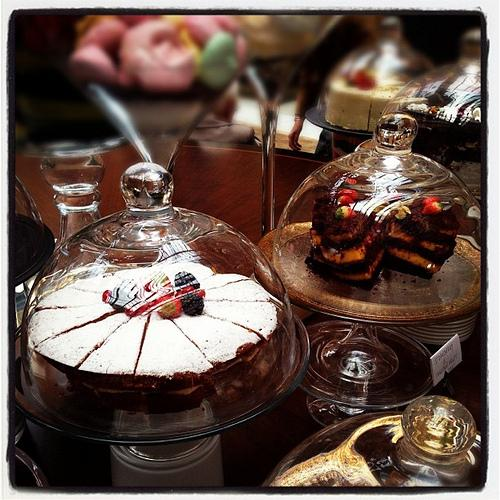What is the outstanding attribute on the image that makes it visually pleasant? The image has a clear reflection on the glass, creating an aesthetically pleasing visual effect. What is the pastry placed in, and what does it rest on? The pastry is placed in a glass cake container under a clear dome lid, resting on a wooden table. Enumerate the fruits on top of the cake. There are strawberries, a blackberry, and red raspberries on the cake. Describe the appearance of the cake's lid and its handle. The dome lid is made of clear glass, and it has a glass handle (knob) on top. Describe any human interaction or presence in the image. There is a hand of a person in the frame, possibly reaching out to grab a tasty dessert. How many cakes are under the dome cap, and are they partially eaten or fully intact? There are two cakes under the dome cap, one of which is partially eaten. What is the setting and ambiance of the scene in the image? The picture is taken in a bakery with a warm ambiance, showing various cakes and pastries in glass containers on a wood counter. Mention the color of the table and the kind of material it is made up of. The table is brown in color and made of wood. Provide a description of the cake along with its toppings and frosting. The cake is chocolate and white in color, with white frosting and topped with strawberries, a blackberry, and red raspberries. What does the sign attached to the cake display look like? The sign is a white and black handwritten note with a text describing the cake. Is the brownie on top of the cake golden in color? There is no brownie mentioned in the image. Additionally, there is no golden color mentioned for any object in the image. Is the blueberry on the cake purple in color? There is no blueberry mentioned in the image. There is a mention of a blackberry, but it is black in color, not purple. Does the blue ribbon surround the cake? There is no mention of any ribbon in the image, let alone a blue one. Are there green apples placed around the wooden table? There is no mention of any apples, green or otherwise, in the image. The focus of the image is on the cake and its surrounding objects, not other fruits. Is the spoon next to the glass lid wooden? There is no spoon mentioned in the image. Additionally, there is no mention of any wooden objects besides the table. Is the cupcake inside the glass container yellow and red? There is no cupcake mentioned in the image. The closest is a mention of a cake with various colors, but not specifically yellow and red. 